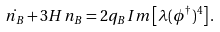Convert formula to latex. <formula><loc_0><loc_0><loc_500><loc_500>\dot { n _ { B } } + 3 H n _ { B } = 2 q _ { B } I m \left [ \lambda ( \phi ^ { \dagger } ) ^ { 4 } \right ] .</formula> 